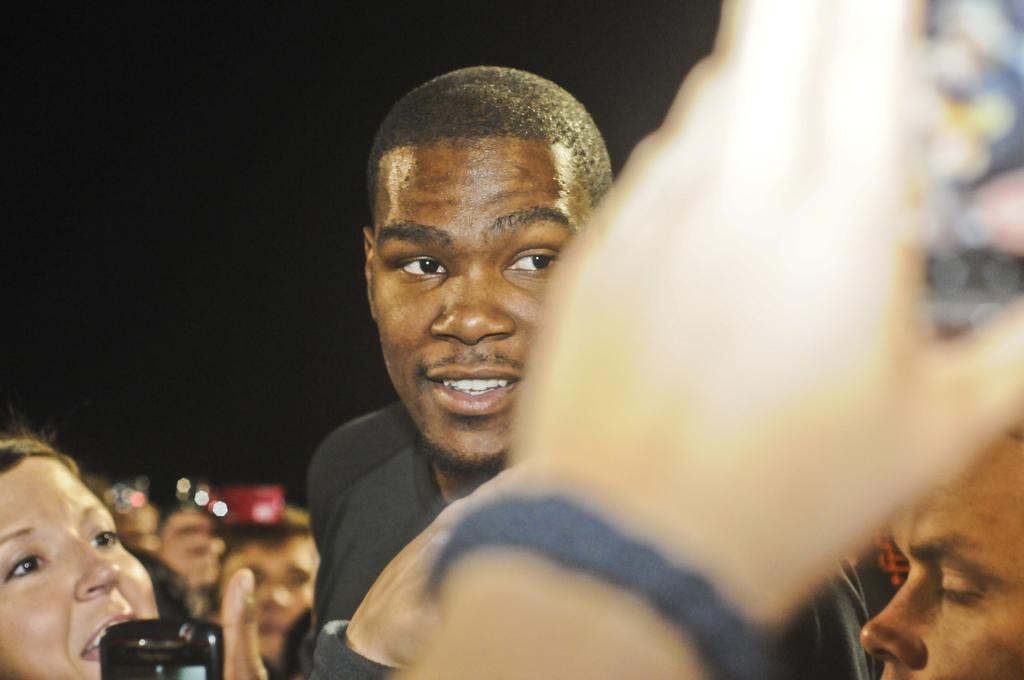How many people are in the image? The number of people in the image is not specified, but there are people present. What can be observed about the background of the image? The background of the image is dark. Can you see any fangs in the image? There is no mention of fangs or any related objects in the image, so we cannot determine if they are present. 